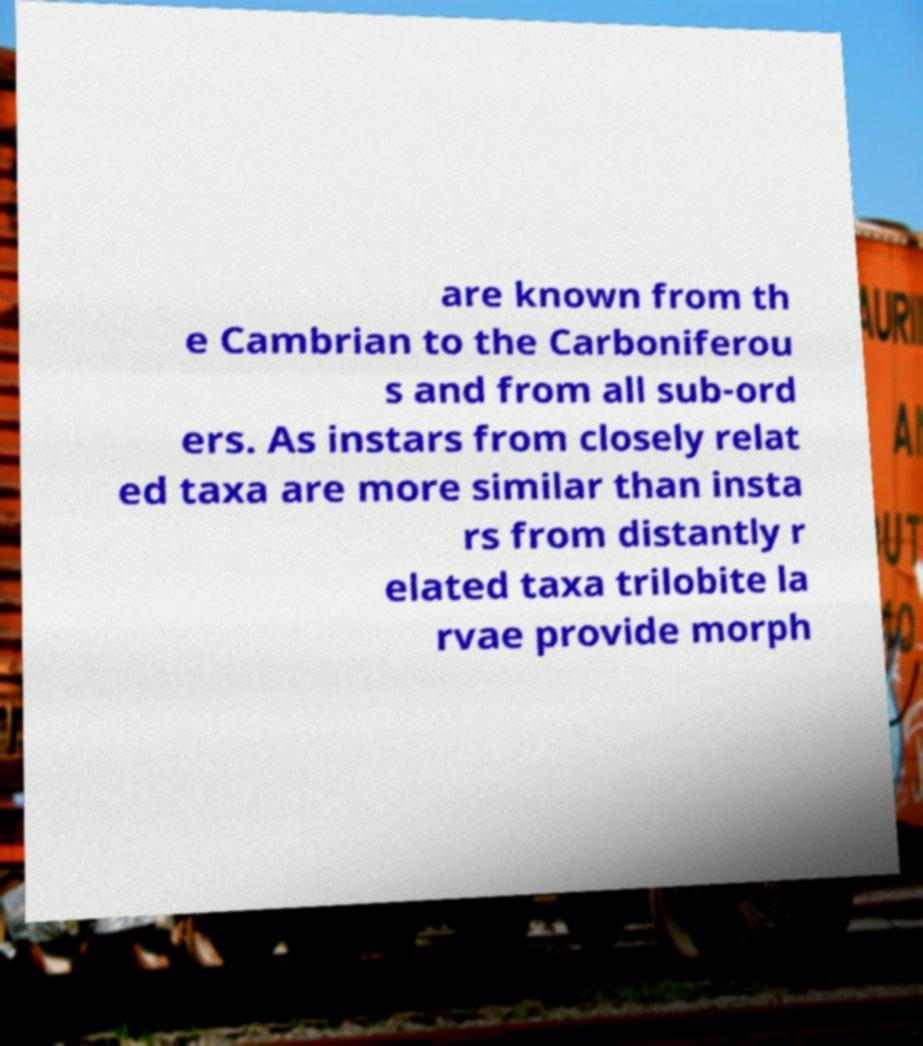Please identify and transcribe the text found in this image. are known from th e Cambrian to the Carboniferou s and from all sub-ord ers. As instars from closely relat ed taxa are more similar than insta rs from distantly r elated taxa trilobite la rvae provide morph 